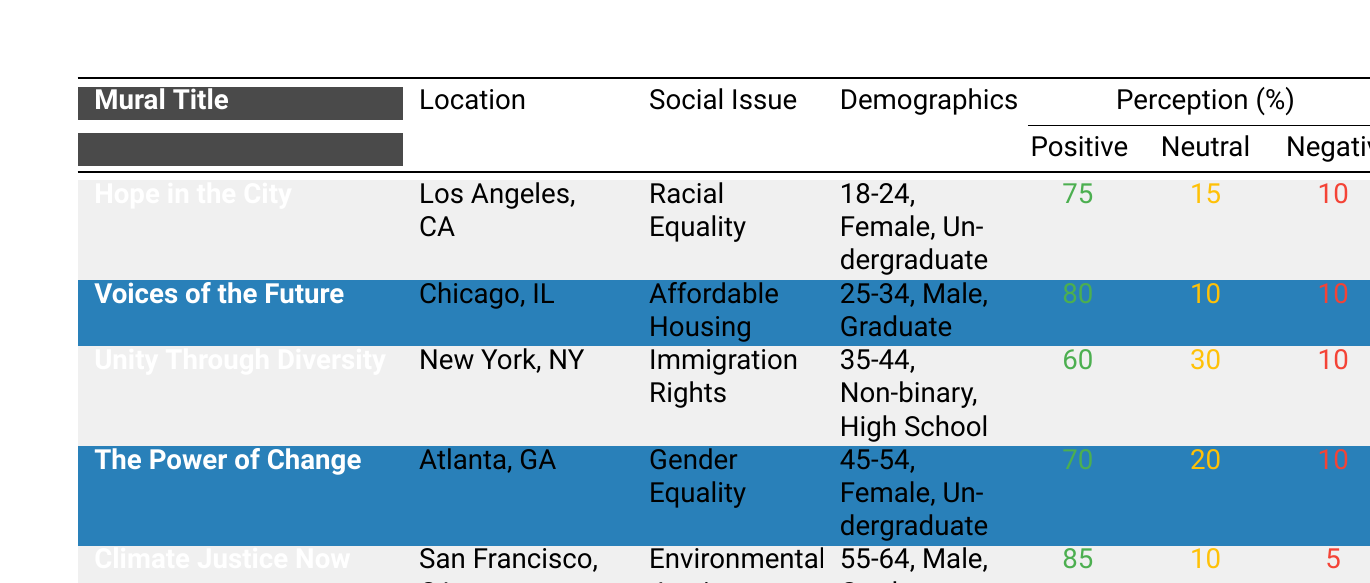What is the social issue depicted in the mural "Climate Justice Now"? The mural "Climate Justice Now" explicitly depicts the social issue of "Environmental Justice" as stated in the data provided.
Answer: Environmental Justice Which mural received the highest percentage of positive perception? By examining the percentages in the table, "Climate Justice Now" received the highest percentage of positive perception at 85%.
Answer: Climate Justice Now What is the total percentage of neutral and negative perception combined for "Unity Through Diversity"? The percentage of neutral perception for "Unity Through Diversity" is 30% and the percentage of negative perception is 10%. Adding these together gives 30 + 10 = 40%.
Answer: 40% Is the demographic for "Voices of the Future" male or female? According to the data, the demographic for "Voices of the Future" is male, as specified in the table.
Answer: Male Which social issue has the lowest positive perception percentage, and what is that percentage? Among the listed murals, "Unity Through Diversity" has the lowest positive perception percentage of 60%.
Answer: Racial Equality, 60% What percentage of respondents had a negative perception of "The Power of Change"? The data shows that "The Power of Change" had a negative perception of 10%, as stated in the table.
Answer: 10% If you average the positive perceptions of all murals, what would that average be? To calculate the average, first add the positive perceptions: 75 + 80 + 60 + 70 + 85 = 370. Then, divide this total by the number of murals, which is 5. Thus, 370/5 = 74.
Answer: 74 Are more than half of the respondents positive about "Hope in the City"? Since "Hope in the City" has a positive perception of 75%, which is greater than 50%, the answer is yes.
Answer: Yes How many murals address the issue of gender-related social themes? The table lists "The Power of Change," which deals with gender equality. It is the only mural addressing gender-related social themes, leading to a count of one.
Answer: 1 